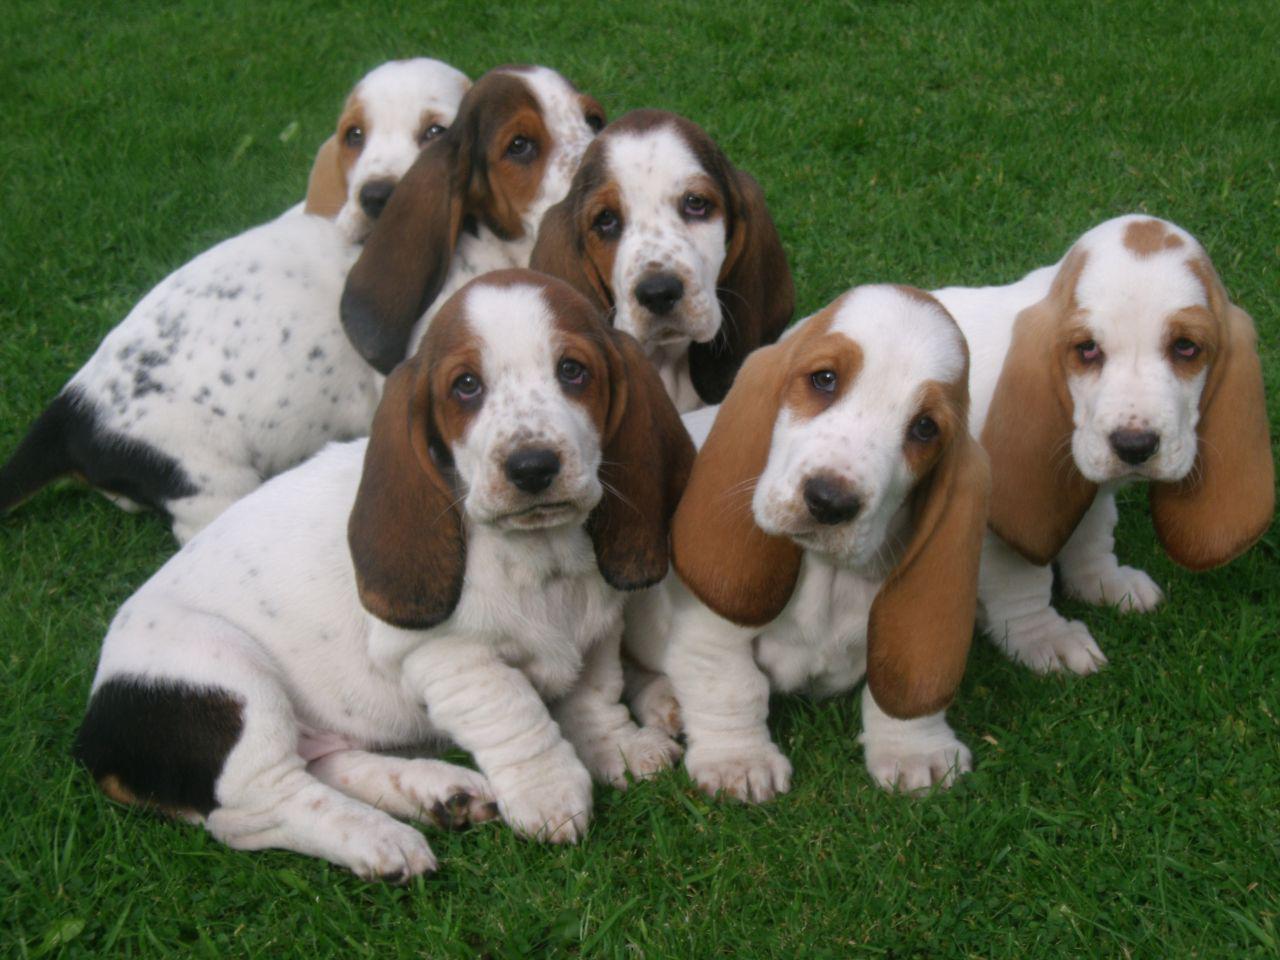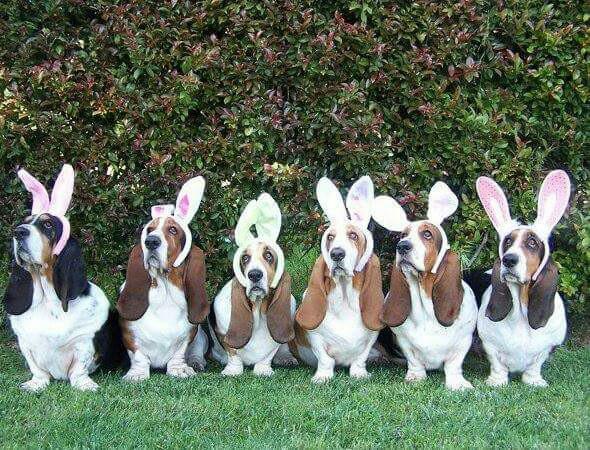The first image is the image on the left, the second image is the image on the right. Examine the images to the left and right. Is the description "An image contains exactly one basset hound, which has tan and white coloring." accurate? Answer yes or no. No. The first image is the image on the left, the second image is the image on the right. Assess this claim about the two images: "There are at least two dogs sitting in the image on the left.". Correct or not? Answer yes or no. Yes. 